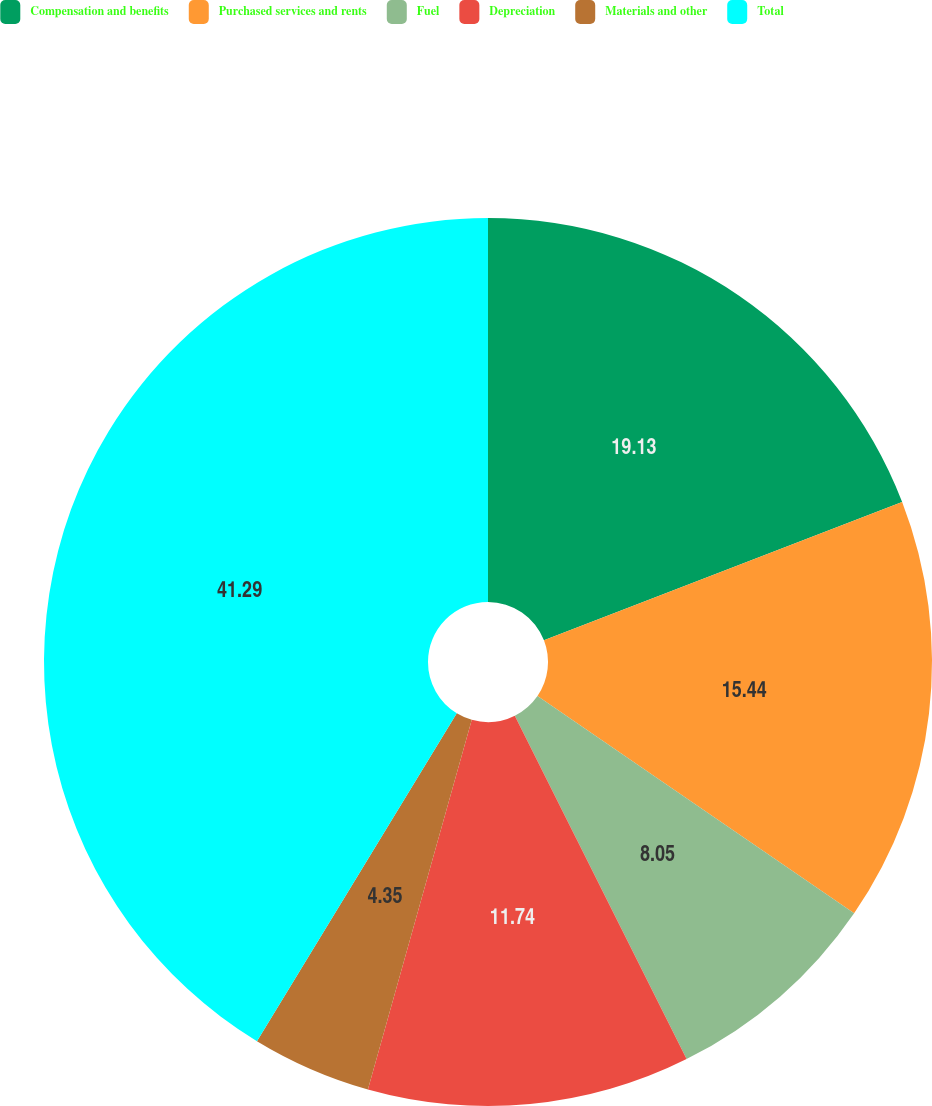Convert chart. <chart><loc_0><loc_0><loc_500><loc_500><pie_chart><fcel>Compensation and benefits<fcel>Purchased services and rents<fcel>Fuel<fcel>Depreciation<fcel>Materials and other<fcel>Total<nl><fcel>19.13%<fcel>15.44%<fcel>8.05%<fcel>11.74%<fcel>4.35%<fcel>41.29%<nl></chart> 